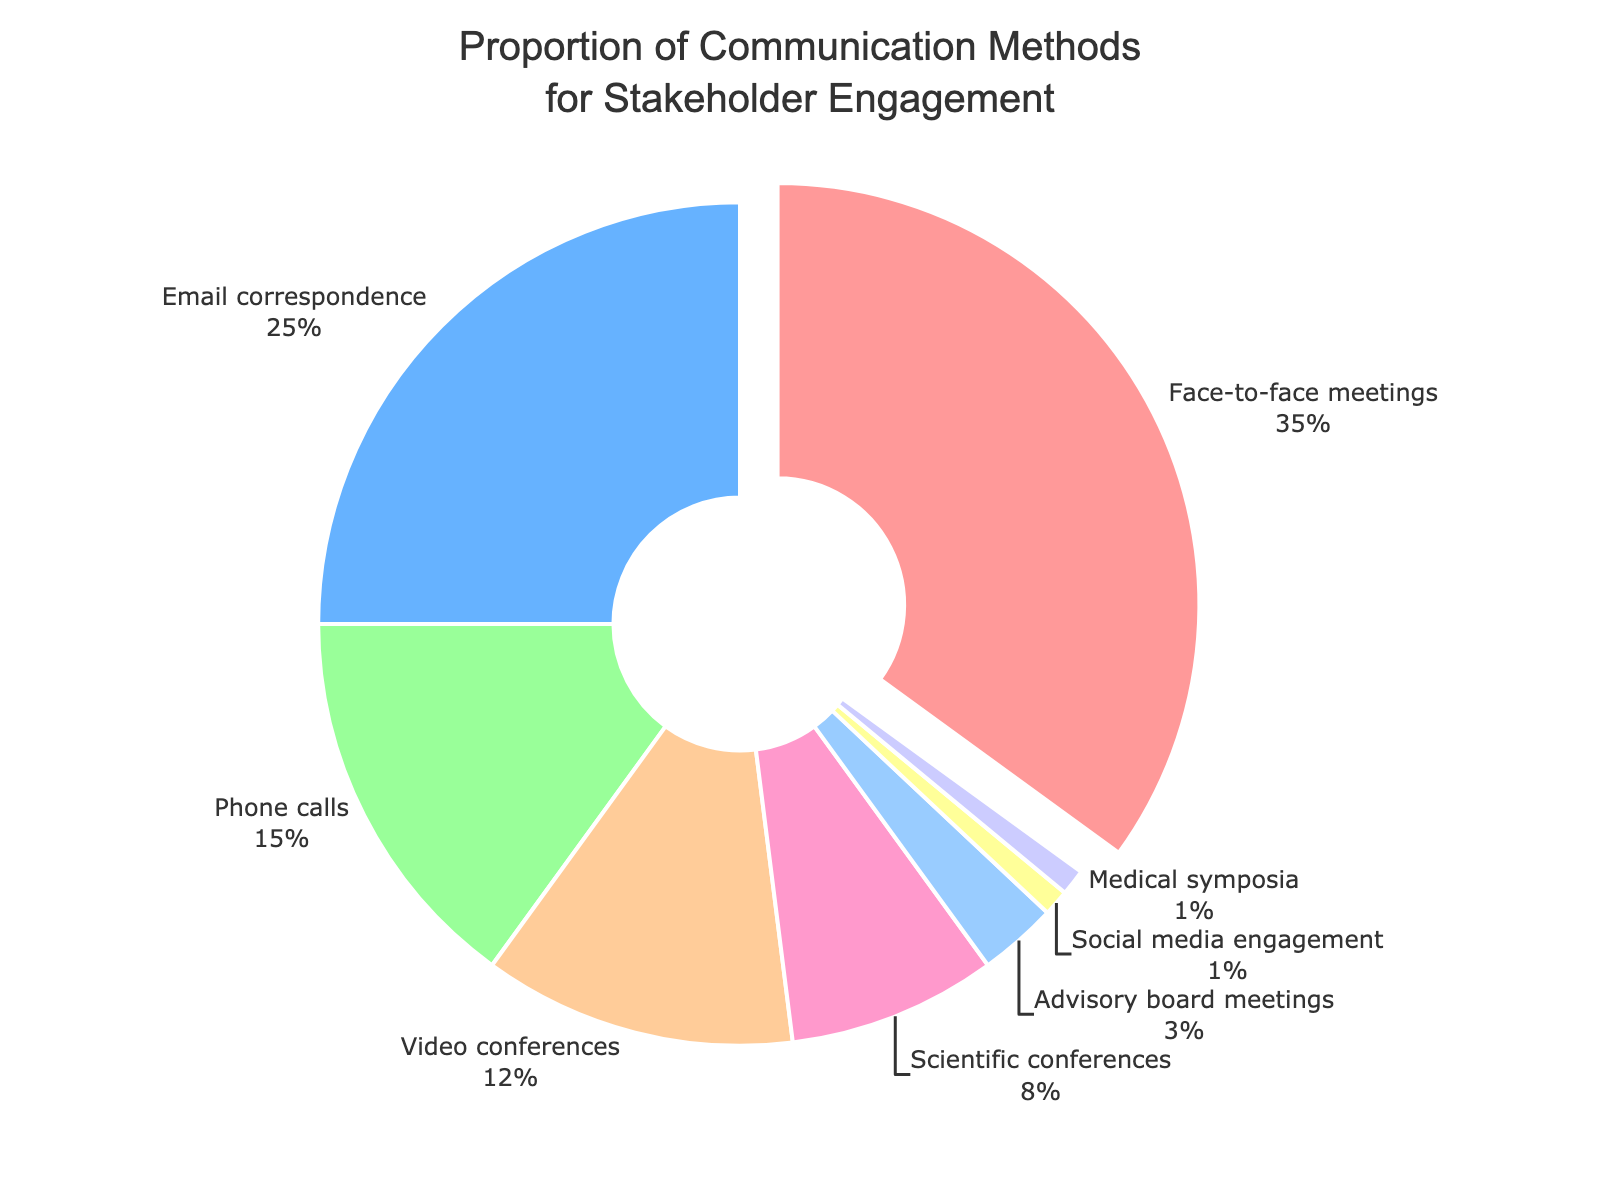Which communication method is used the most? The largest segment in the pie chart represents Face-to-face meetings.
Answer: Face-to-face meetings Which two communication methods have the smallest proportion? The two smallest segments in the pie chart represent Social media engagement and Medical symposia.
Answer: Social media engagement and Medical symposia How much greater is the percentage of Face-to-face meetings compared to Video conferences? Face-to-face meetings have 35% and Video conferences have 12%; the difference is 35% - 12% = 23%.
Answer: 23% What is the combined percentage of Email correspondence and Phone calls? Email correspondence is 25% and Phone calls are 15%; their combined percentage is 25% + 15% = 40%.
Answer: 40% What is the mean percentage of all the communication methods? Sum all the percentages (35% + 25% + 15% + 12% + 8% + 3% + 1% + 1% = 100%) and divide by the number of methods (8); the mean percentage is 100% / 8 = 12.5%.
Answer: 12.5% Which communication methods have a proportion greater than the overall mean percentage? The overall mean percentage is 12.5%, and the methods with higher percentages are Face-to-face meetings (35%), Email correspondence (25%), and Phone calls (15%).
Answer: Face-to-face meetings, Email correspondence, and Phone calls Which communication method is represented by the orange segment? By viewing the color attributes in the pie chart, the orange segment represents Email correspondence.
Answer: Email correspondence Are Video conferences used more frequently than Scientific conferences? Video conferences have a proportion of 12%, whereas Scientific conferences have a proportion of 8%; therefore, Video conferences are used more frequently.
Answer: Yes What is the total percentage of methods that are used for direct interaction (Face-to-face meetings, Phone calls, and Video conferences)? Face-to-face meetings are 35%, Phone calls are 15%, and Video conferences are 12%; their combined percentage is 35% + 15% + 12% = 62%.
Answer: 62% How does the proportion of Advisory board meetings compare to Scientific conferences? Advisory board meetings are 3% and Scientific conferences are 8%; Scientific conferences have a higher proportion.
Answer: Scientific conferences have a higher proportion 